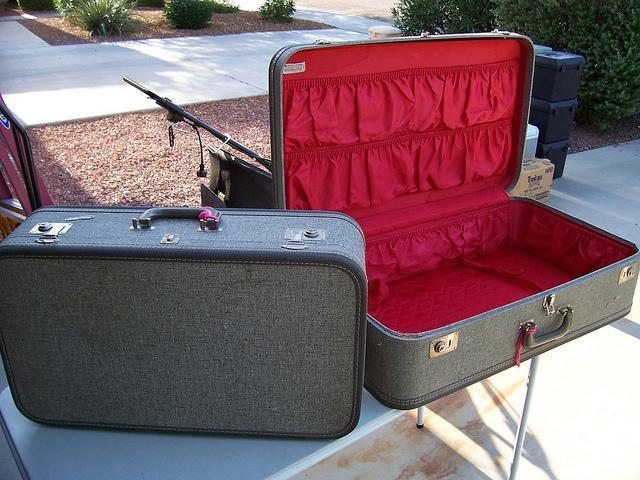How many suitcases can you see?
Give a very brief answer. 2. 